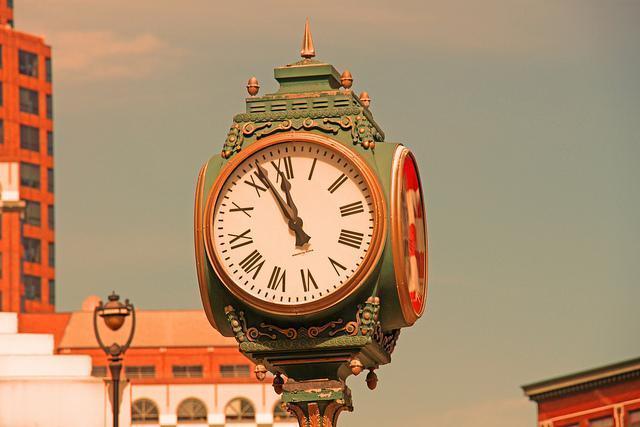How many clocks are there?
Give a very brief answer. 2. 